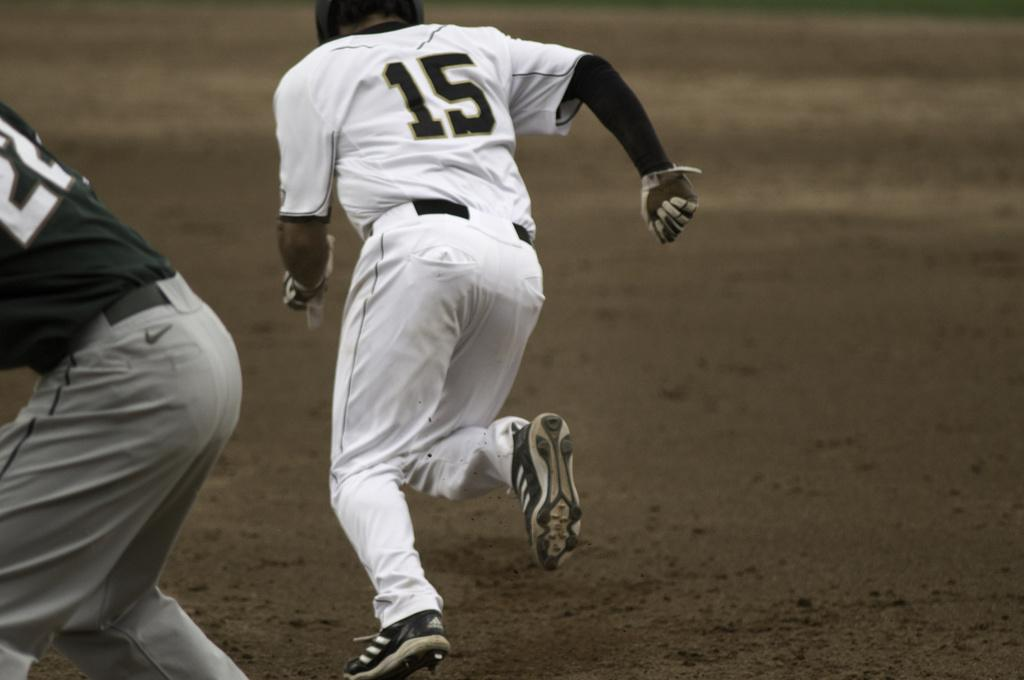What is the main action being performed by the person in the image? The person in the image is running on the ground. Can you describe the other person in the image? There is another person beside the running person in the image. What type of rhythm can be heard from the eggs in the image? There are no eggs present in the image, so there is no rhythm to be heard from them. 